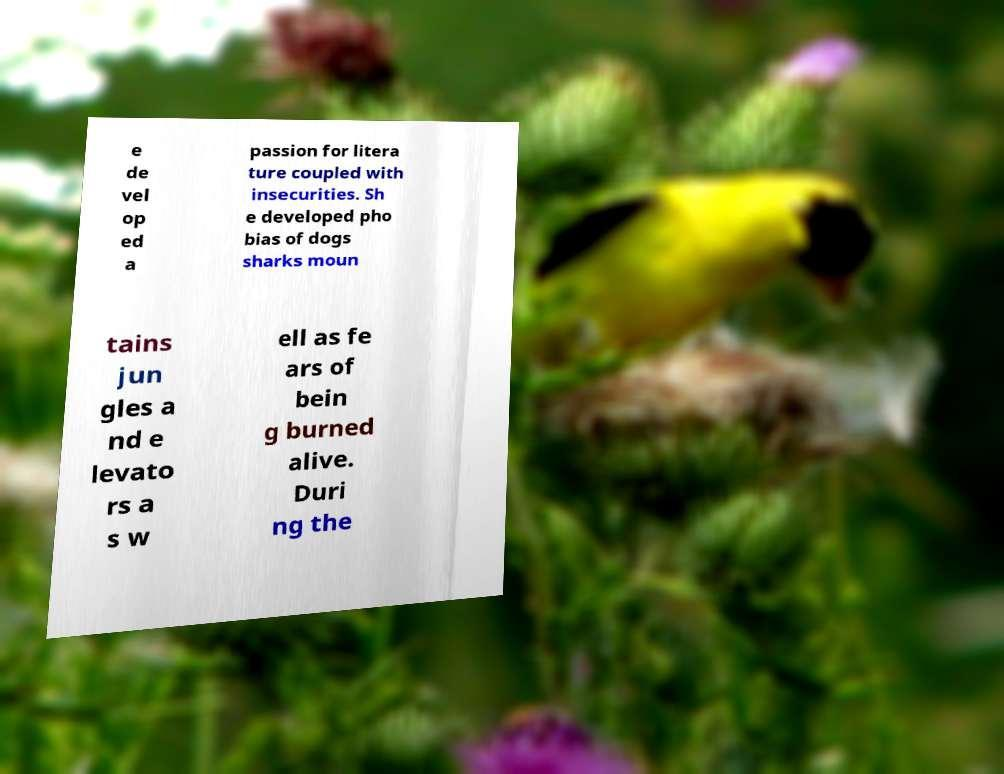Can you read and provide the text displayed in the image?This photo seems to have some interesting text. Can you extract and type it out for me? e de vel op ed a passion for litera ture coupled with insecurities. Sh e developed pho bias of dogs sharks moun tains jun gles a nd e levato rs a s w ell as fe ars of bein g burned alive. Duri ng the 